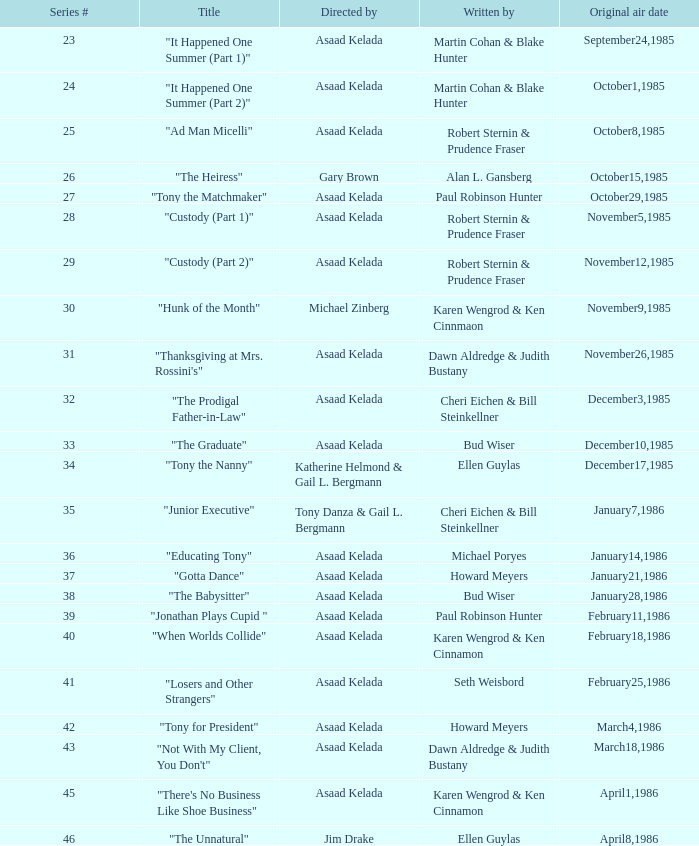Who were the authors of series episode #25? Robert Sternin & Prudence Fraser. 